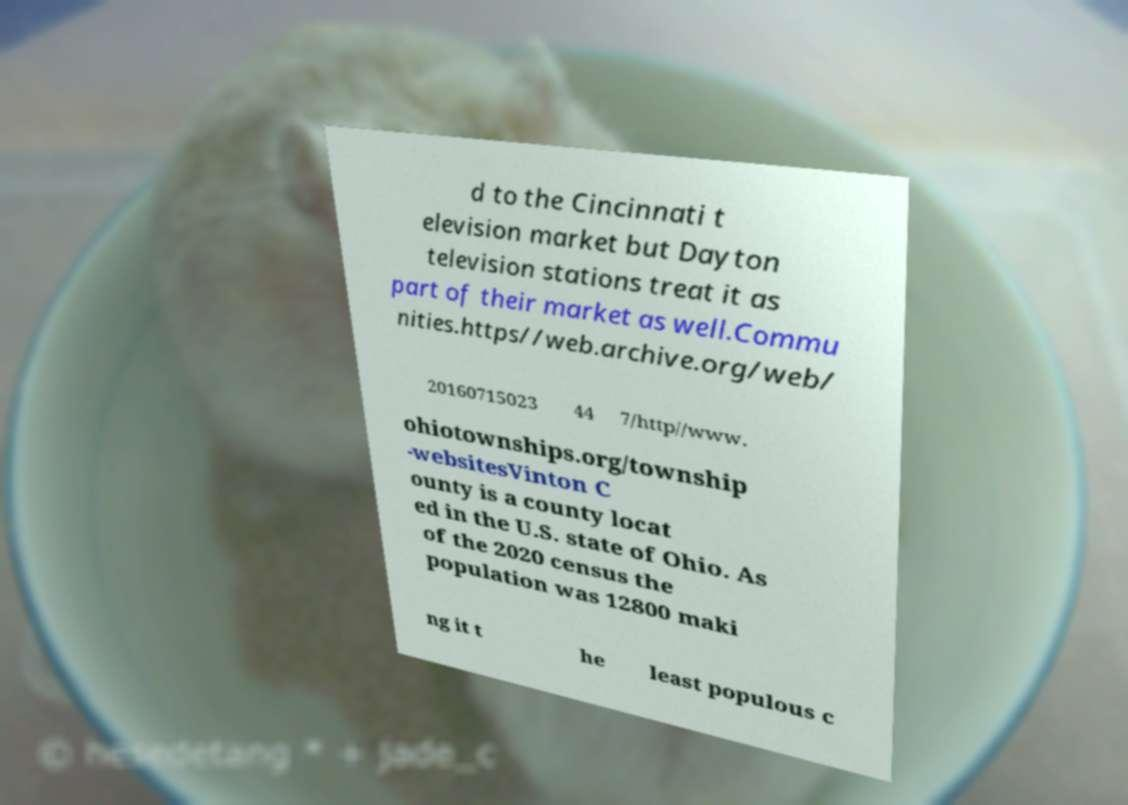For documentation purposes, I need the text within this image transcribed. Could you provide that? d to the Cincinnati t elevision market but Dayton television stations treat it as part of their market as well.Commu nities.https//web.archive.org/web/ 20160715023 44 7/http//www. ohiotownships.org/township -websitesVinton C ounty is a county locat ed in the U.S. state of Ohio. As of the 2020 census the population was 12800 maki ng it t he least populous c 